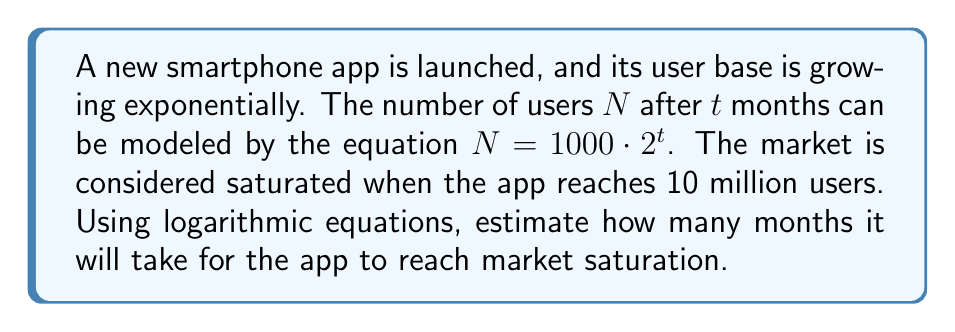Give your solution to this math problem. Let's approach this step-by-step:

1) We're given the equation $N = 1000 \cdot 2^t$, where $N$ is the number of users and $t$ is time in months.

2) We want to find $t$ when $N = 10,000,000$ (10 million users).

3) Let's substitute this into our equation:

   $10,000,000 = 1000 \cdot 2^t$

4) Divide both sides by 1000:

   $10,000 = 2^t$

5) Now, we can use logarithms to solve for $t$. Let's use log base 2 on both sides:

   $\log_2(10,000) = \log_2(2^t)$

6) Using the logarithm property $\log_a(a^x) = x$, we get:

   $\log_2(10,000) = t$

7) We can calculate $\log_2(10,000)$ using the change of base formula:

   $t = \frac{\log(10,000)}{\log(2)}$

8) Using a calculator or computer:

   $t \approx 13.29$

Therefore, it will take approximately 13.29 months for the app to reach market saturation.
Answer: $13.29$ months 